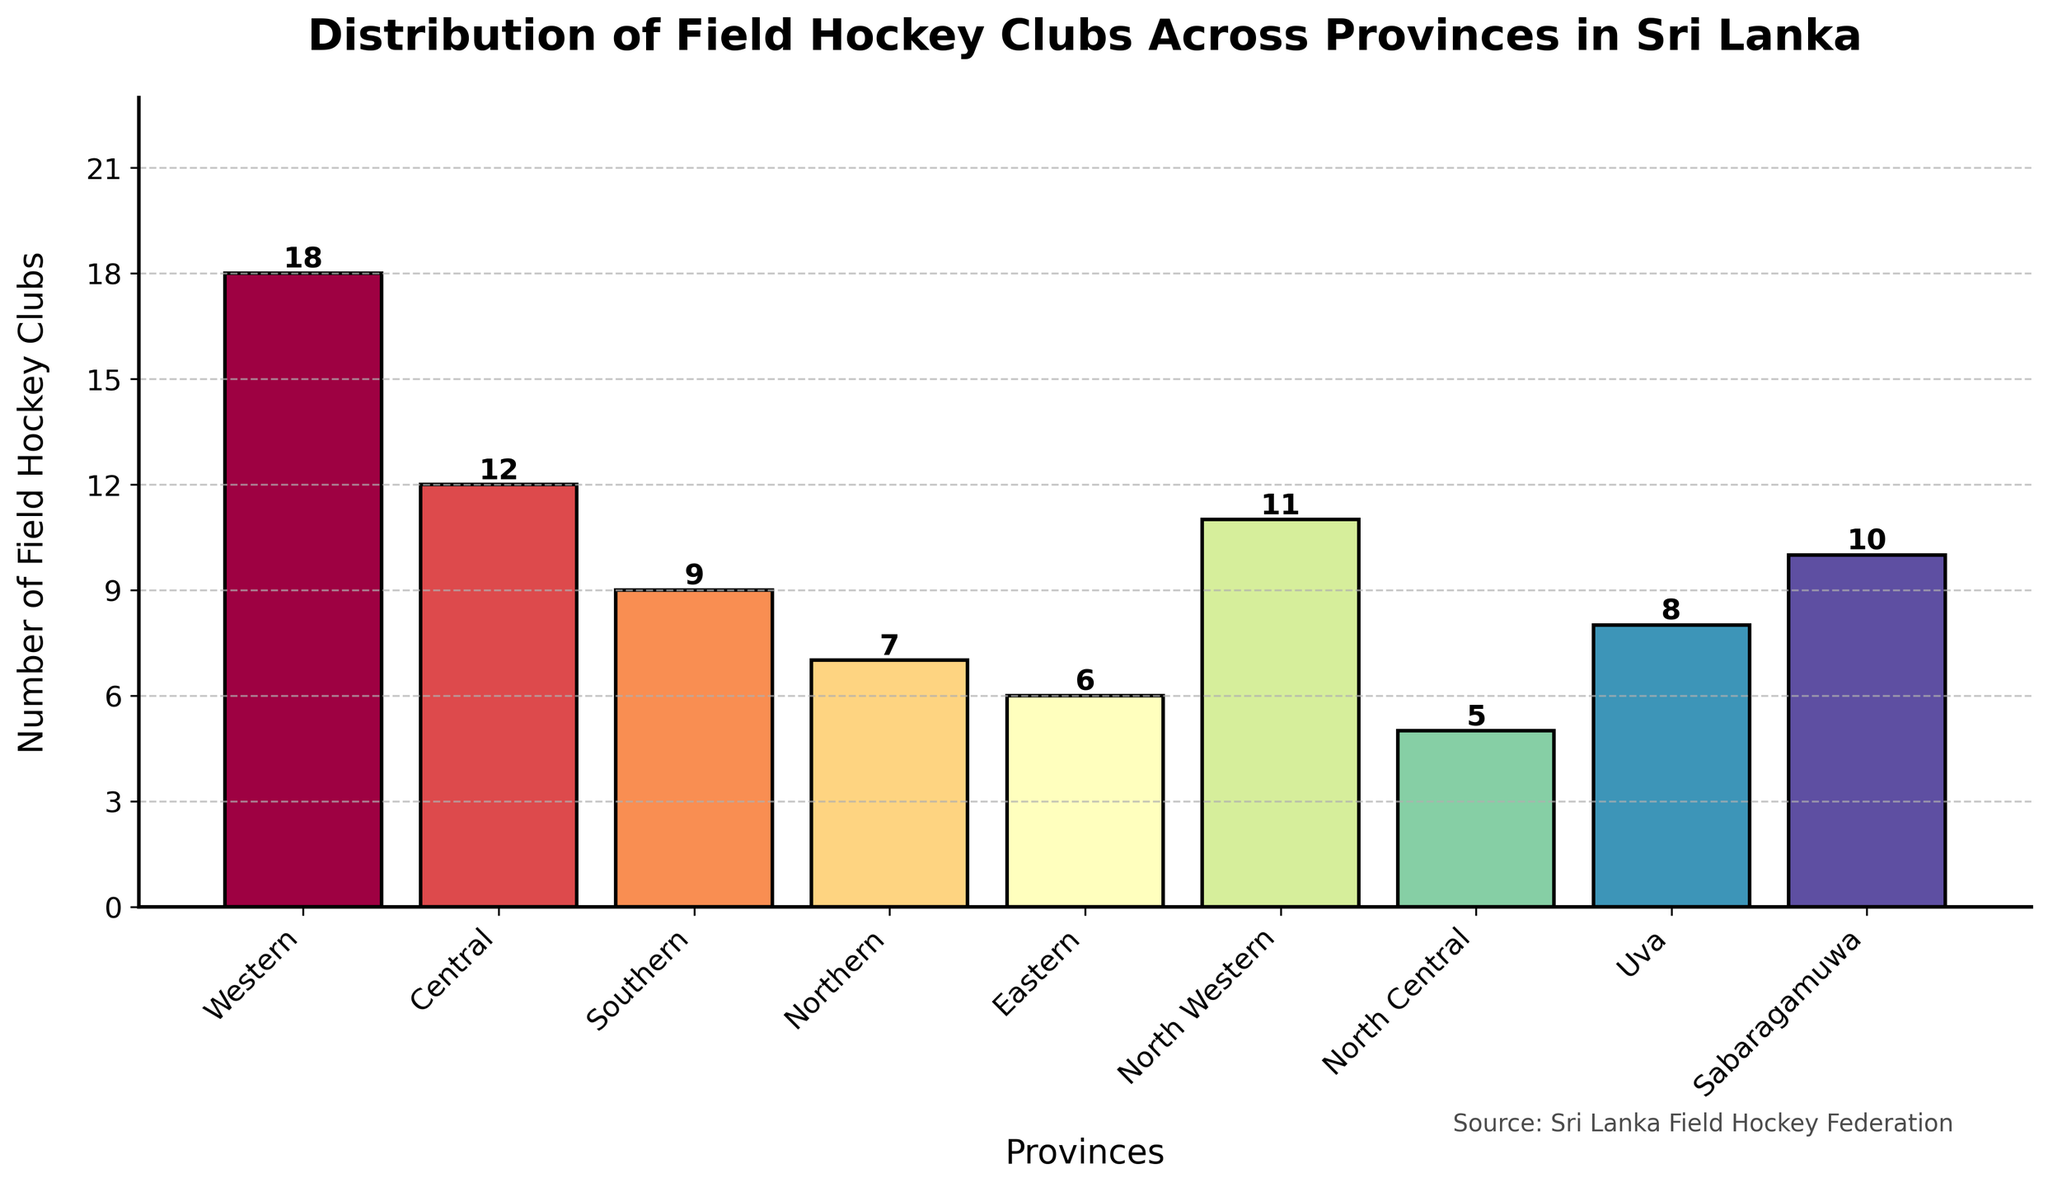Which province has the highest number of field hockey clubs? To find the province with the highest number of field hockey clubs, look for the tallest bar in the bar chart. The Western province has the tallest bar.
Answer: Western What is the difference in the number of field hockey clubs between the province with the most clubs and the province with the least? The province with the most clubs is Western (18 clubs) and the province with the least is North Central (5 clubs). The difference is 18 - 5.
Answer: 13 Among the provinces Central, Southern, and Northern, which one has the highest number of field hockey clubs? Compare the heights of bars for Central, Southern, and Northern provinces. Central has 12 clubs, Southern has 9 clubs, and Northern has 7 clubs. The tallest bar is for the Central province.
Answer: Central How many provinces have more than 10 field hockey clubs? Count the number of bars with a height greater than 10. Western (18), Central (12), North Western (11), and Sabaragamuwa (10) make up four provinces.
Answer: 3 What is the total number of field hockey clubs across all provinces? Sum the values of all bars: 18 (Western) + 12 (Central) + 9 (Southern) + 7 (Northern) + 6 (Eastern) + 11 (North Western) + 5 (North Central) + 8 (Uva) + 10 (Sabaragamuwa).
Answer: 86 What is the average number of field hockey clubs per province? Divide the total number of field hockey clubs by the number of provinces: 86 clubs / 9 provinces.
Answer: 9.56 Which provinces have the same number of field hockey clubs? Look for bars of the same height. There are no two bars with the exact same height.
Answer: None Is there a significant visual difference in the number of clubs between the Northern and Southern provinces? Compare the heights of the bars for Northern (7 clubs) and Southern (9 clubs). The bar for Southern is slightly taller, indicating a small difference of 2 clubs.
Answer: No If you combine the number of clubs in North Western and North Central provinces, how many clubs do you have? Add the number of clubs in North Western (11) and North Central (5): 11 + 5.
Answer: 16 Which province has the least number of field hockey clubs, and how many clubs does it have? Find the shortest bar, which represents North Central province with 5 clubs.
Answer: North Central, 5 